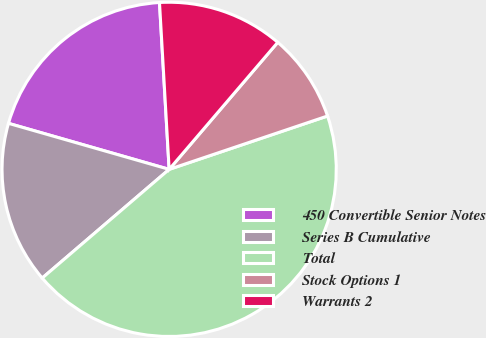Convert chart to OTSL. <chart><loc_0><loc_0><loc_500><loc_500><pie_chart><fcel>450 Convertible Senior Notes<fcel>Series B Cumulative<fcel>Total<fcel>Stock Options 1<fcel>Warrants 2<nl><fcel>19.64%<fcel>15.71%<fcel>43.9%<fcel>8.57%<fcel>12.18%<nl></chart> 